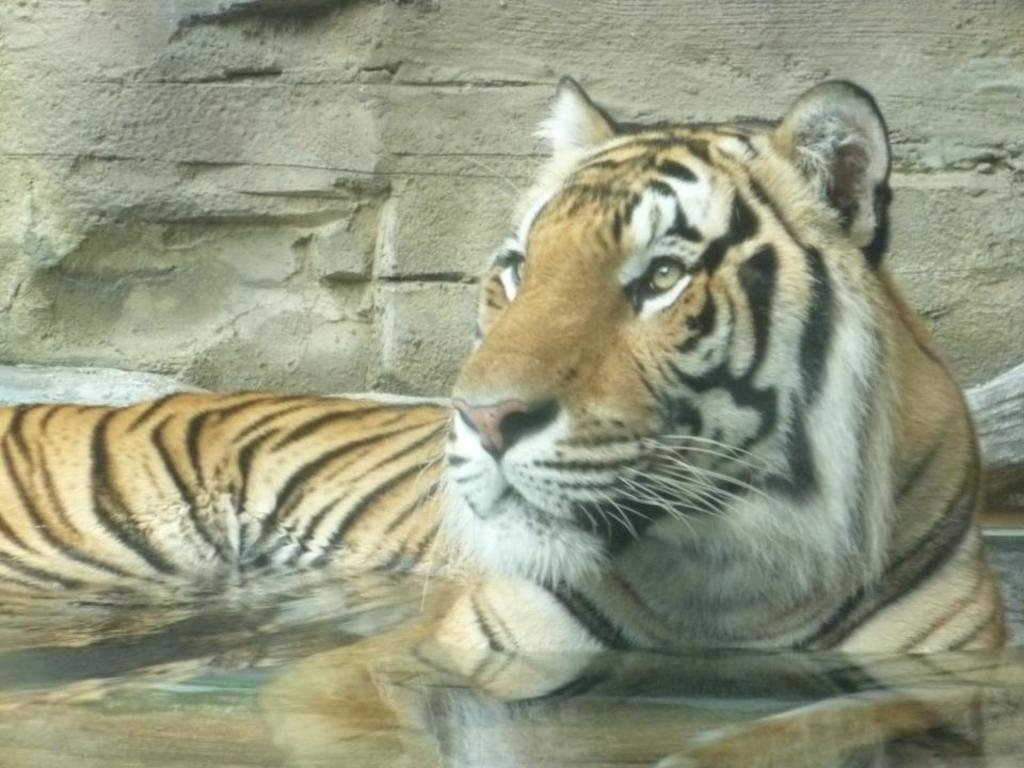What animal is in the water in the image? There is a tiger in the water in the image. What can be seen in the background of the image? There is a wall in the background of the image. How many frames are surrounding the tiger in the image? There are no frames present in the image; it is a photograph or digital image of a tiger in the water. 